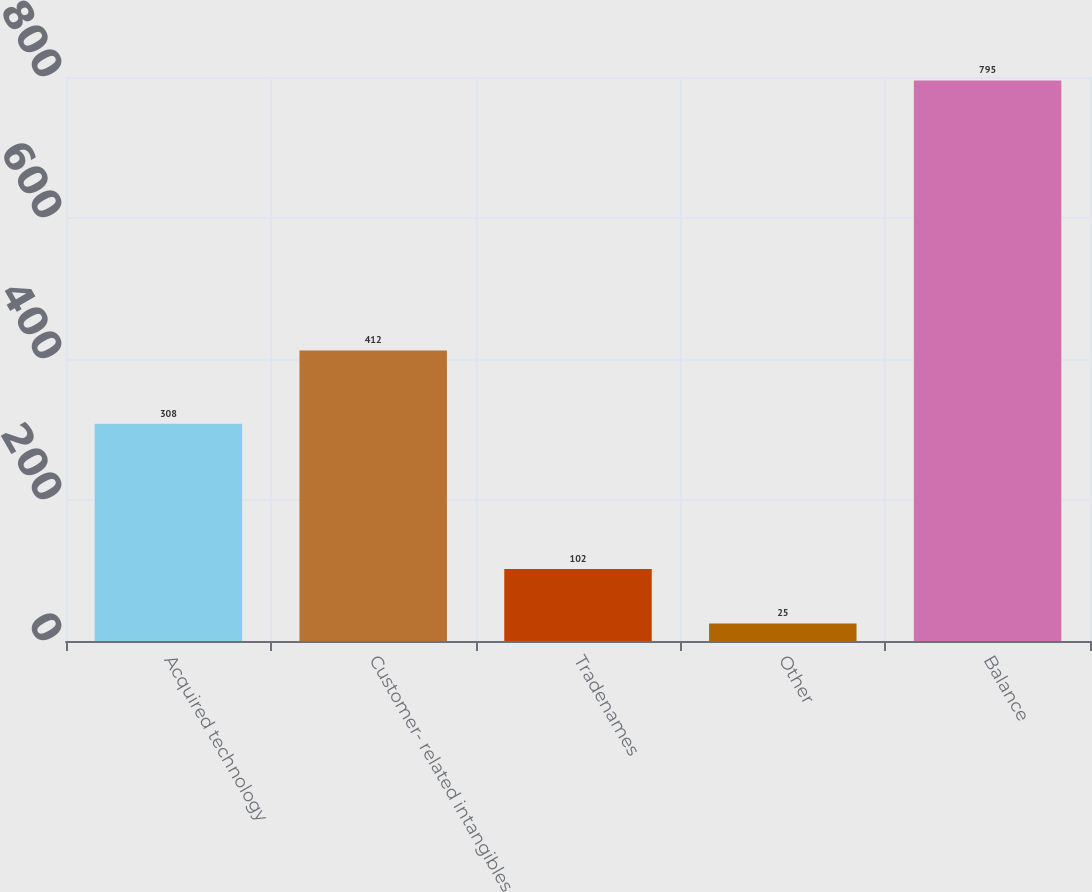Convert chart. <chart><loc_0><loc_0><loc_500><loc_500><bar_chart><fcel>Acquired technology<fcel>Customer- related intangibles<fcel>Tradenames<fcel>Other<fcel>Balance<nl><fcel>308<fcel>412<fcel>102<fcel>25<fcel>795<nl></chart> 